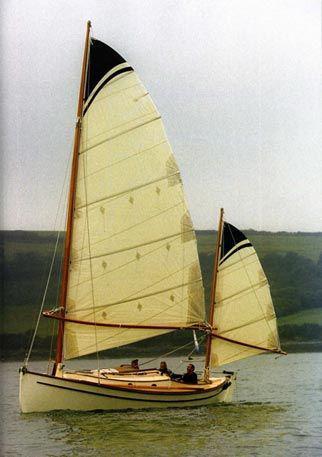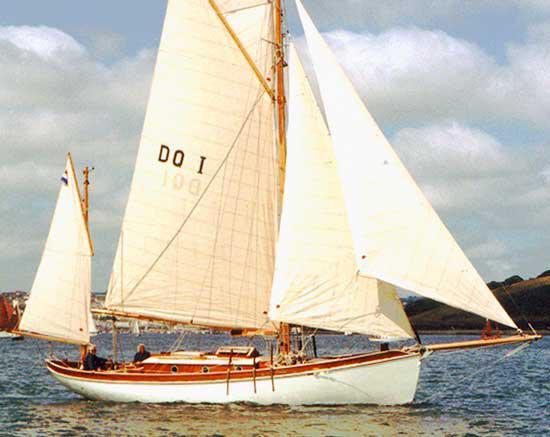The first image is the image on the left, the second image is the image on the right. Analyze the images presented: Is the assertion "At least one boat is docked near a building in one of the images." valid? Answer yes or no. No. 